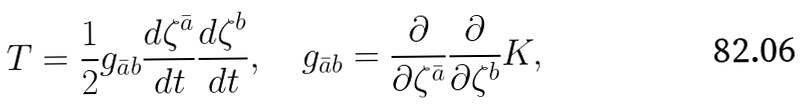<formula> <loc_0><loc_0><loc_500><loc_500>T = \frac { 1 } { 2 } g _ { \bar { a } b } \frac { d \zeta ^ { \bar { a } } } { d t } \frac { d \zeta ^ { b } } { d t } , \quad g _ { \bar { a } b } = \frac { \partial } { \partial \zeta ^ { \bar { a } } } \frac { \partial } { \partial \zeta ^ { b } } K ,</formula> 